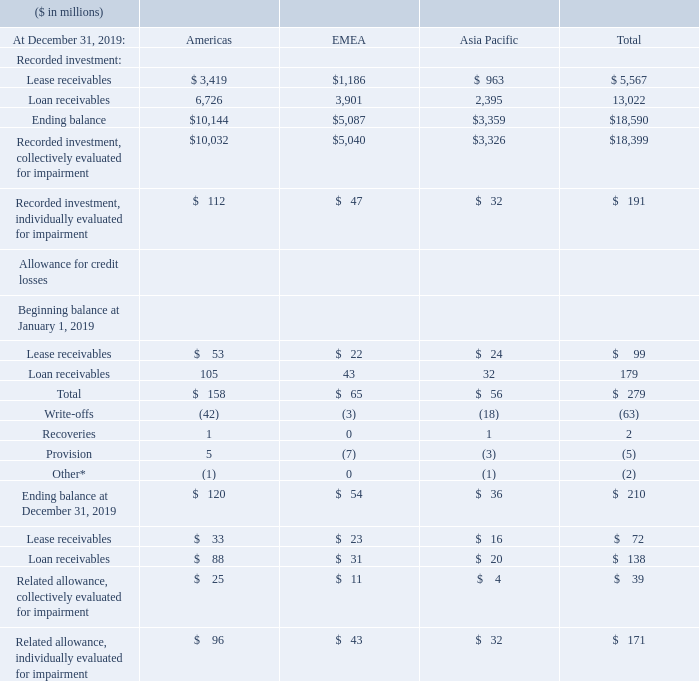The following tables present the recorded investment by portfolio segment and by class, excluding commercial financing receivables and other miscellaneous financing receivables at December 31, 2019 and 2018. Commercial financing receivables are excluded from the presentation of financing receivables by portfolio segment, as they are short term in nature and the current estimated risk of loss and resulting impact to the company’s financing results are not material.
Write-offs of lease receivables and loan receivables were $16 million and $47 million, respectively, for the year ended December 31, 2019. Provisions for credit losses recorded for lease receivables and loan receivables were a release of $6 million and an addition of $2 million, respectively, for the year ended December 31, 2019.
The average recorded investment of impaired leases and loans for Americas, EMEA and Asia Pacific was $138 million, $49 million and $45 million, respectively, for the year ended December 31, 2019. Both interest income recognized, and interest income recognized on a cash basis on impaired leases and loans were immaterial for the year ended December 31, 2019.
Why are Commercial financing receivables are excluded from financing receivables? They are short term in nature and the current estimated risk of loss and resulting impact to the company’s financing results are not material. What were the write-offs in December 2019? $16 million. What is the average recorded investment of impaired leases and loans for Americas for December 2019? $138 million. What is the average Recorded investment of Lease receivables for Americas and EMEA for December 2019?
Answer scale should be: million. (3,419+1,186) / 2 
Answer: 2302.5. What is the average Recorded investment of Loan receivables for Americas and EMEA for December 2019?
Answer scale should be: million. (6,726+3,901) / 2 
Answer: 5313.5. What is the average Allowance for credit losses of Lease receivables at the beginning of January 2019?
Answer scale should be: million. 99/ 3
Answer: 33. 